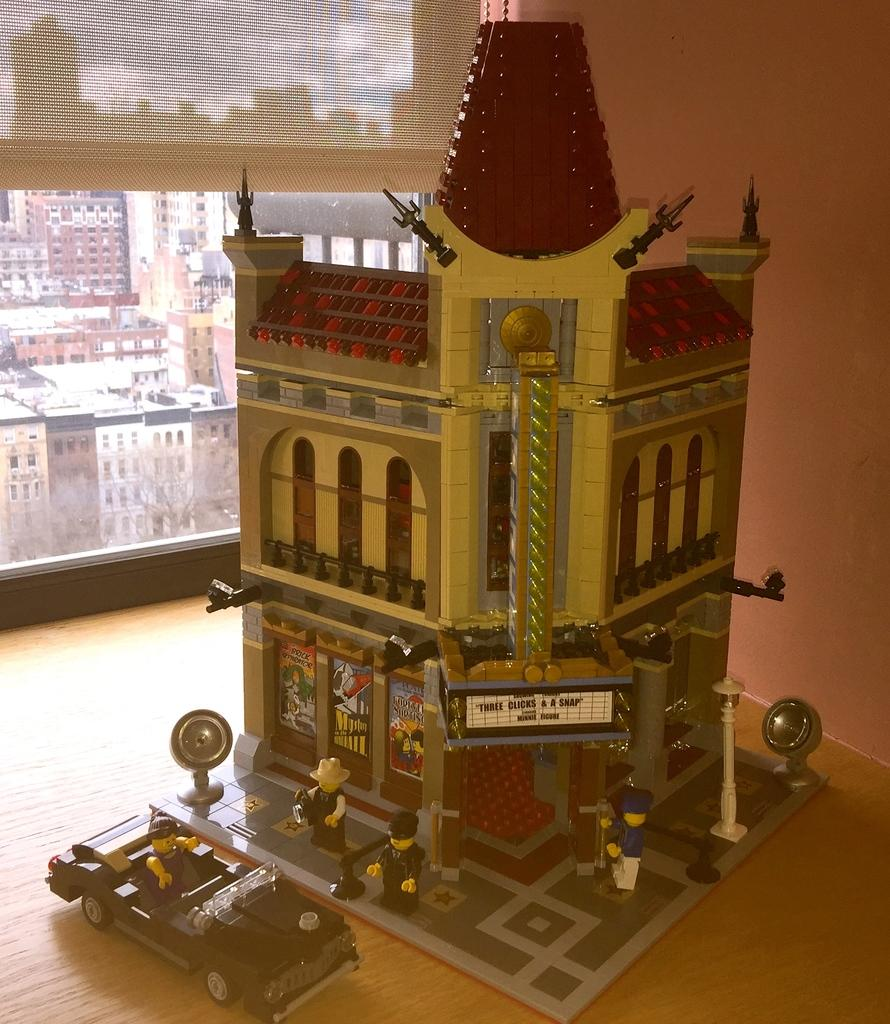What is the main subject of the image? The main subject of the image is a toy building. What else can be seen near the toy building? There are toy persons standing in front of the toy building and a toy car beside it. What can be seen in the background of the image? There are buildings visible in the background of the image. What is your opinion on the geese flying over the toy building in the image? There are no geese present in the image, so it is not possible to provide an opinion on them. 